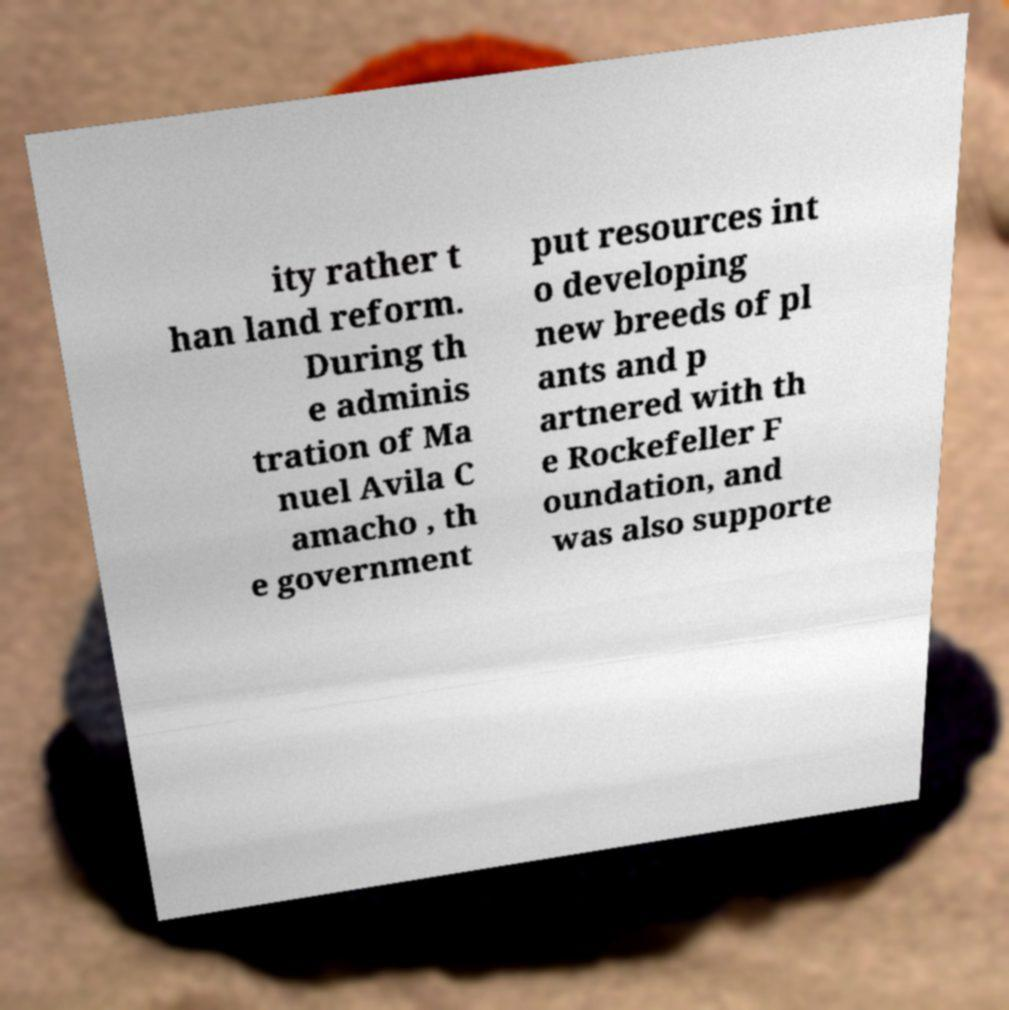Could you assist in decoding the text presented in this image and type it out clearly? ity rather t han land reform. During th e adminis tration of Ma nuel Avila C amacho , th e government put resources int o developing new breeds of pl ants and p artnered with th e Rockefeller F oundation, and was also supporte 